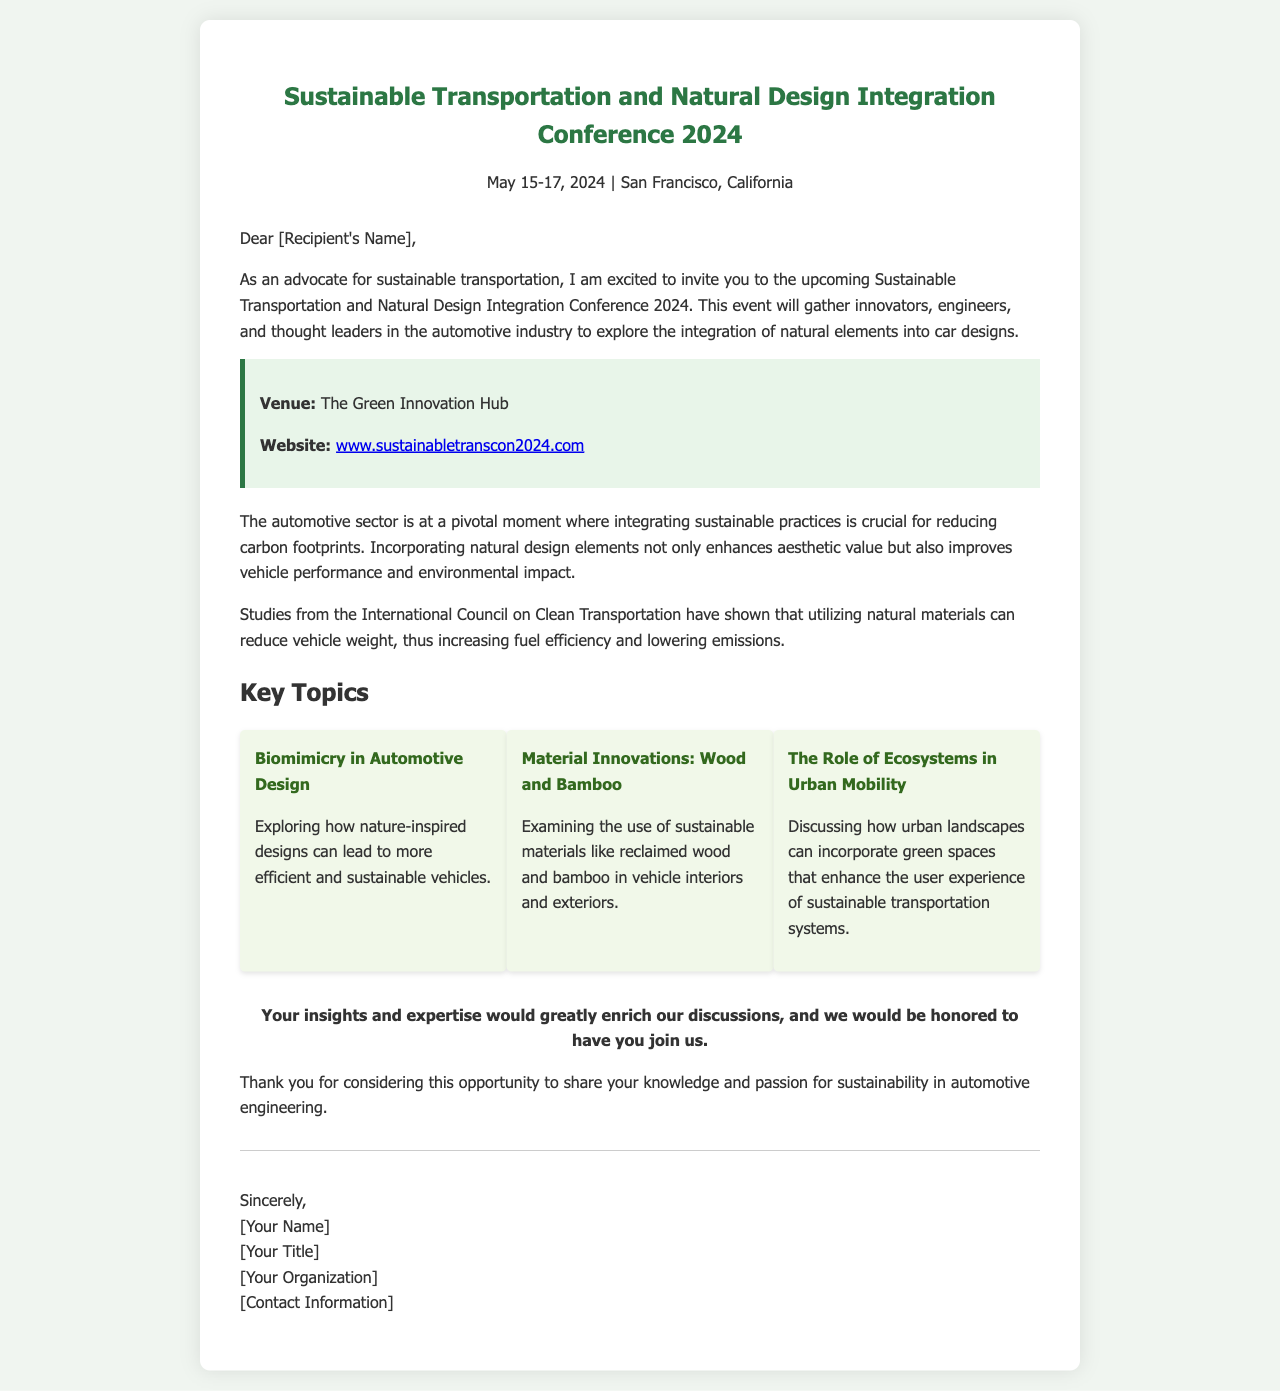What are the conference dates? The conference dates are explicitly stated in the document as May 15-17, 2024.
Answer: May 15-17, 2024 Where is the conference venue located? The venue of the conference is mentioned in the document as The Green Innovation Hub.
Answer: The Green Innovation Hub What is the website for the conference? The document provides a link to the conference website as www.sustainabletranscon2024.com.
Answer: www.sustainabletranscon2024.com What is a key topic discussed related to nature-inspired designs? The key topic involving nature is indicated as "Biomimicry in Automotive Design."
Answer: Biomimicry in Automotive Design Which material innovations are examined in the conference? The document highlights "Wood and Bamboo" as part of the material innovations discussed.
Answer: Wood and Bamboo What type of professionals is the conference targeting? The conference targets innovators, engineers, and thought leaders in the automotive industry.
Answer: Innovators, engineers, and thought leaders What is the primary purpose of the conference? The document states that the conference aims to explore the integration of natural elements into car designs.
Answer: Explore the integration of natural elements into car designs What is one benefit of using natural materials mentioned in the document? The document notes that utilizing natural materials can reduce vehicle weight, thereby increasing fuel efficiency.
Answer: Reduce vehicle weight Who signs the invitation letter? The document indicates that the letter is signed by the person identified as [Your Name].
Answer: [Your Name] 